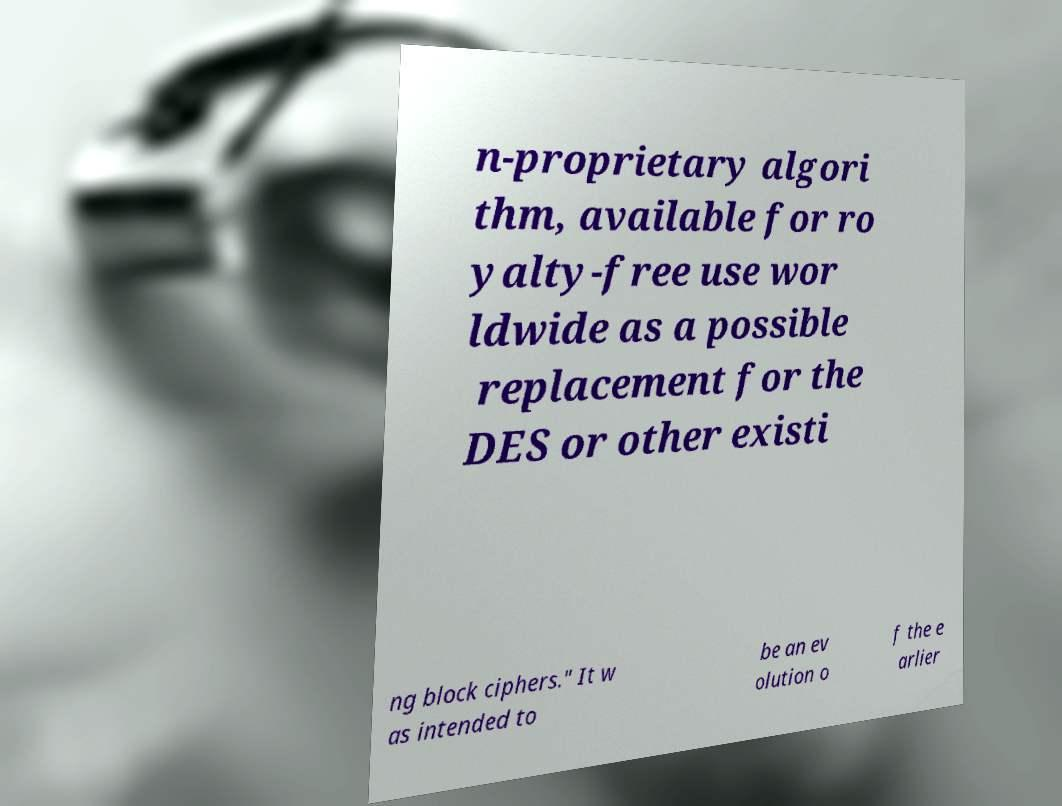Please read and relay the text visible in this image. What does it say? n-proprietary algori thm, available for ro yalty-free use wor ldwide as a possible replacement for the DES or other existi ng block ciphers." It w as intended to be an ev olution o f the e arlier 